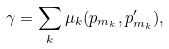Convert formula to latex. <formula><loc_0><loc_0><loc_500><loc_500>\gamma = \sum _ { k } \mu _ { k } ( p _ { m _ { k } } , p ^ { \prime } _ { m _ { k } } ) ,</formula> 